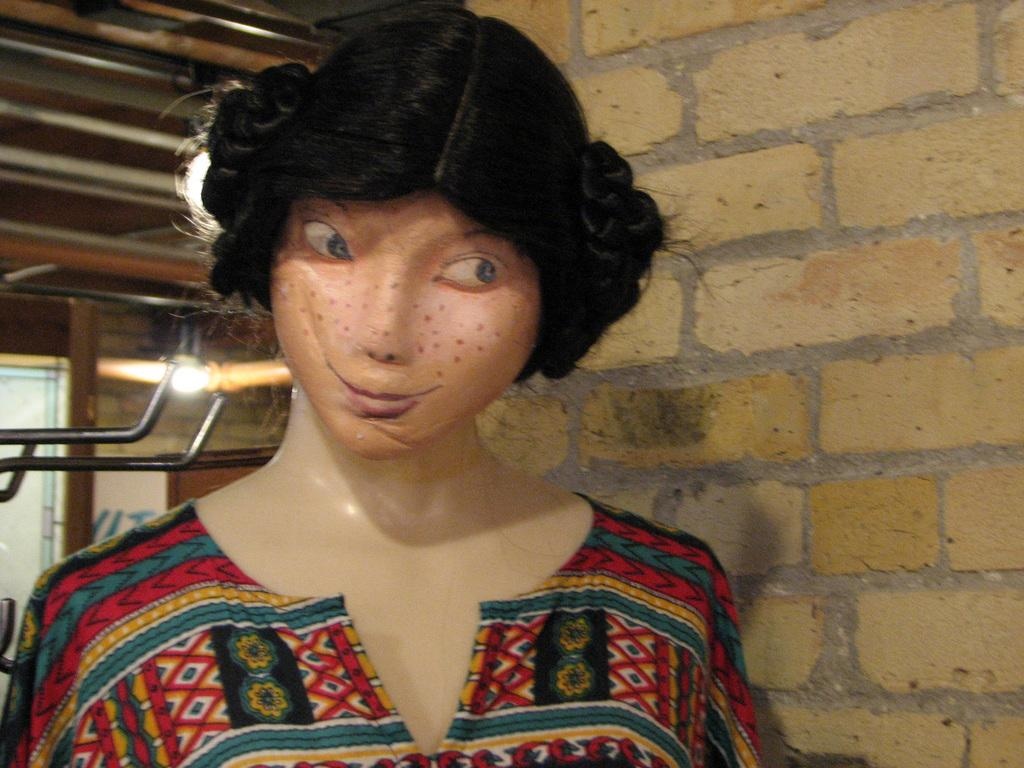What is the main subject of the image? There is a mannequin in the image. What is the mannequin wearing? The mannequin is wearing a colorful dress. What can be seen in the background of the image? There is a brick wall and rods in the background of the image. Can you describe the lighting in the image? There is light visible in the image. What is the mannequin's mom doing in the image? There is no person, including a mom, present in the image; it only features a mannequin. 